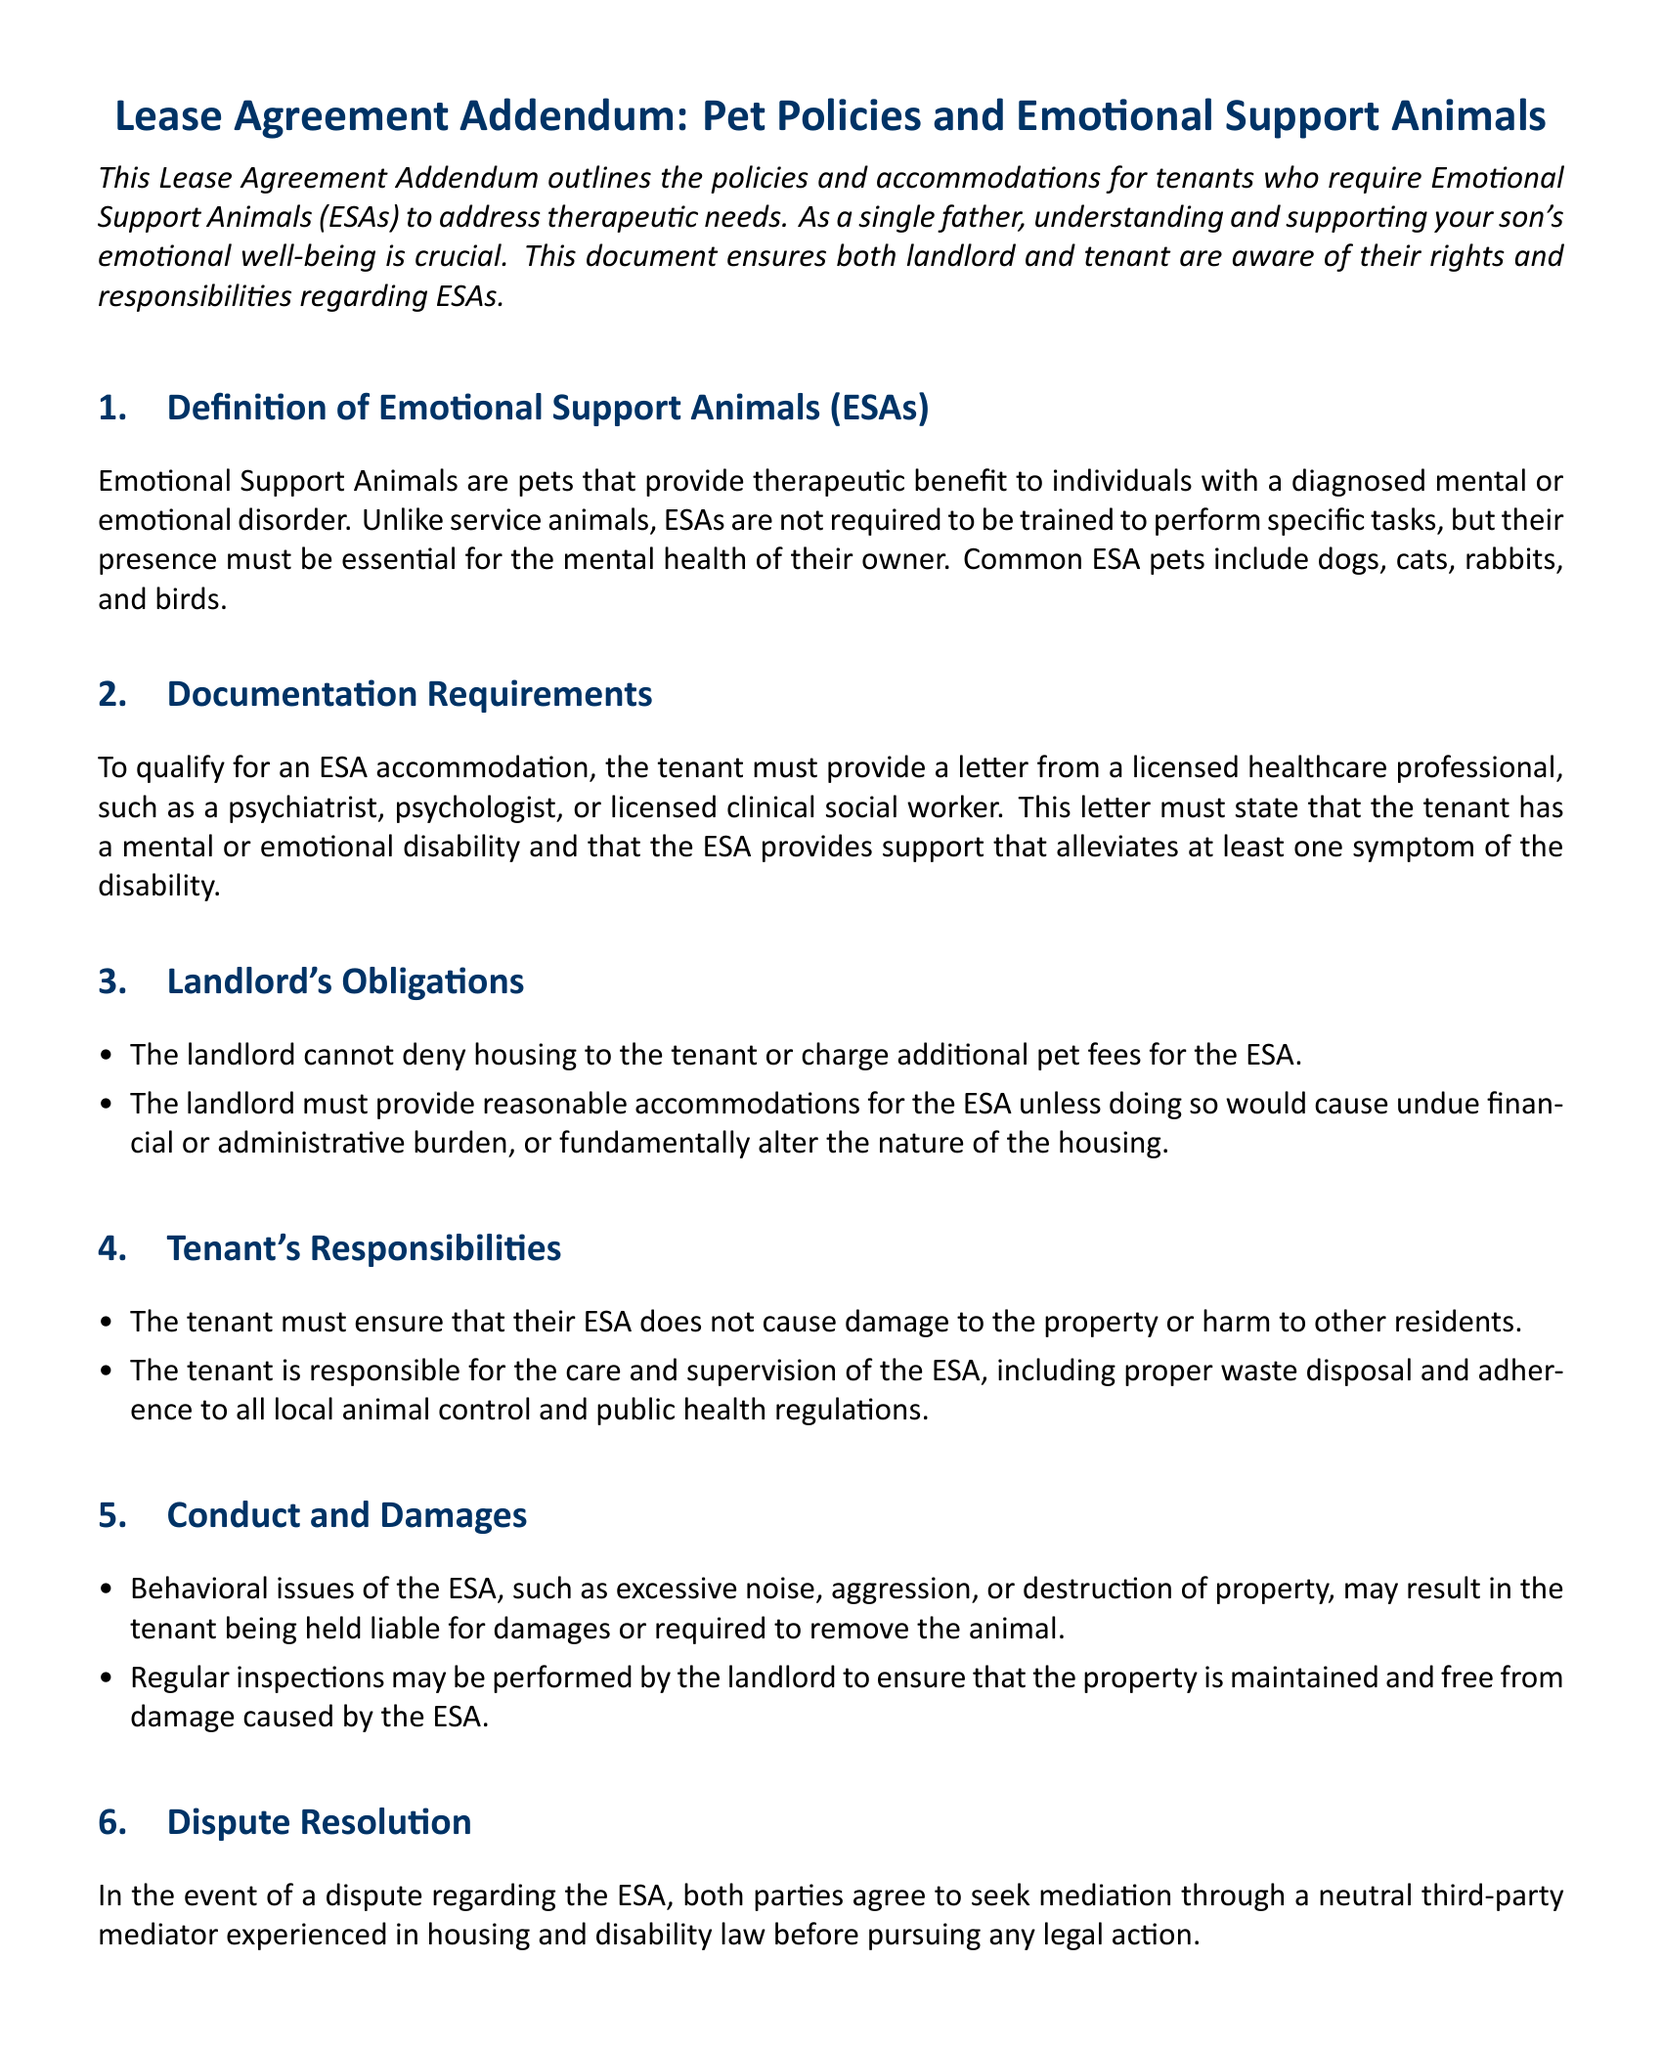What is the definition of Emotional Support Animals? The definition outlines that ESAs are pets providing therapeutic benefit to individuals with a diagnosed mental or emotional disorder.
Answer: Pets providing therapeutic benefit What must a tenant provide to qualify for an ESA accommodation? The document states that the tenant must provide a letter from a licensed healthcare professional.
Answer: A letter from a licensed healthcare professional What are the landlord's obligations regarding ESAs? The landlord's obligations include not denying housing and providing reasonable accommodations for the ESA.
Answer: Not deny housing and provide reasonable accommodations What are the tenant's responsibilities regarding their ESA? The tenant's responsibilities include ensuring the ESA does not cause damage and proper care and supervision.
Answer: Ensure no damage and provide proper care What could result from behavioral issues of the ESA? The document states that behavioral issues could lead to the tenant being held liable for damages or needing to remove the animal.
Answer: Liability for damages or removal What must both parties do in the event of a dispute regarding the ESA? Both parties must seek mediation through a neutral third-party mediator.
Answer: Seek mediation What right does the landlord have if the tenant no longer requires the ESA? The landlord reserves the right to revoke the ESA accommodation.
Answer: Revoking ESA accommodation Which animals are commonly recognized as ESAs? The document lists dogs, cats, rabbits, and birds as common ESA pets.
Answer: Dogs, cats, rabbits, and birds What may trigger regular inspections by the landlord? Regular inspections may be performed to ensure the property is maintained and free from damage caused by the ESA.
Answer: Damage caused by the ESA 